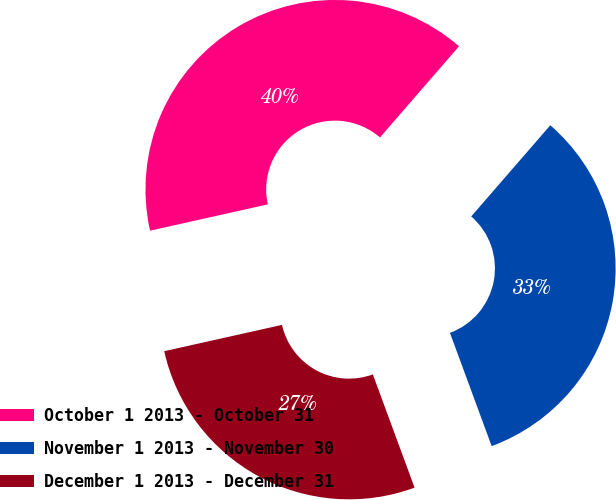Convert chart. <chart><loc_0><loc_0><loc_500><loc_500><pie_chart><fcel>October 1 2013 - October 31<fcel>November 1 2013 - November 30<fcel>December 1 2013 - December 31<nl><fcel>39.87%<fcel>33.01%<fcel>27.12%<nl></chart> 